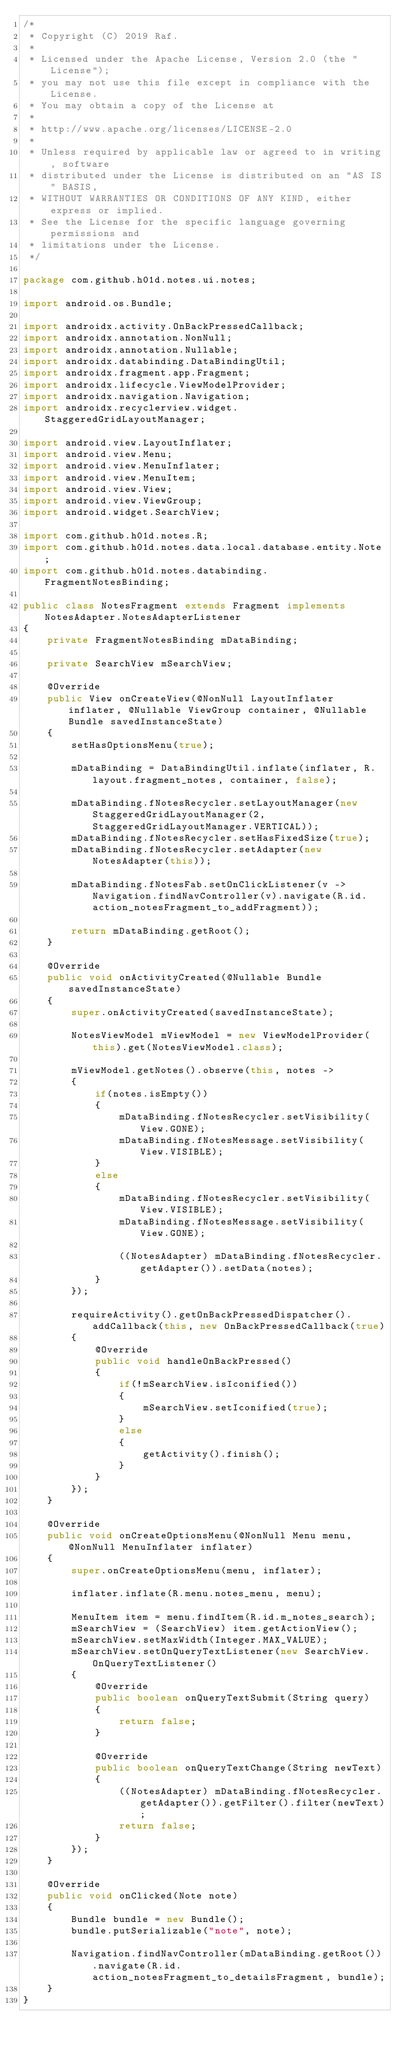Convert code to text. <code><loc_0><loc_0><loc_500><loc_500><_Java_>/*
 * Copyright (C) 2019 Raf.
 *
 * Licensed under the Apache License, Version 2.0 (the "License");
 * you may not use this file except in compliance with the License.
 * You may obtain a copy of the License at
 *
 * http://www.apache.org/licenses/LICENSE-2.0
 *
 * Unless required by applicable law or agreed to in writing, software
 * distributed under the License is distributed on an "AS IS" BASIS,
 * WITHOUT WARRANTIES OR CONDITIONS OF ANY KIND, either express or implied.
 * See the License for the specific language governing permissions and
 * limitations under the License.
 */

package com.github.h01d.notes.ui.notes;

import android.os.Bundle;

import androidx.activity.OnBackPressedCallback;
import androidx.annotation.NonNull;
import androidx.annotation.Nullable;
import androidx.databinding.DataBindingUtil;
import androidx.fragment.app.Fragment;
import androidx.lifecycle.ViewModelProvider;
import androidx.navigation.Navigation;
import androidx.recyclerview.widget.StaggeredGridLayoutManager;

import android.view.LayoutInflater;
import android.view.Menu;
import android.view.MenuInflater;
import android.view.MenuItem;
import android.view.View;
import android.view.ViewGroup;
import android.widget.SearchView;

import com.github.h01d.notes.R;
import com.github.h01d.notes.data.local.database.entity.Note;
import com.github.h01d.notes.databinding.FragmentNotesBinding;

public class NotesFragment extends Fragment implements NotesAdapter.NotesAdapterListener
{
    private FragmentNotesBinding mDataBinding;

    private SearchView mSearchView;

    @Override
    public View onCreateView(@NonNull LayoutInflater inflater, @Nullable ViewGroup container, @Nullable Bundle savedInstanceState)
    {
        setHasOptionsMenu(true);

        mDataBinding = DataBindingUtil.inflate(inflater, R.layout.fragment_notes, container, false);

        mDataBinding.fNotesRecycler.setLayoutManager(new StaggeredGridLayoutManager(2, StaggeredGridLayoutManager.VERTICAL));
        mDataBinding.fNotesRecycler.setHasFixedSize(true);
        mDataBinding.fNotesRecycler.setAdapter(new NotesAdapter(this));

        mDataBinding.fNotesFab.setOnClickListener(v -> Navigation.findNavController(v).navigate(R.id.action_notesFragment_to_addFragment));

        return mDataBinding.getRoot();
    }

    @Override
    public void onActivityCreated(@Nullable Bundle savedInstanceState)
    {
        super.onActivityCreated(savedInstanceState);

        NotesViewModel mViewModel = new ViewModelProvider(this).get(NotesViewModel.class);

        mViewModel.getNotes().observe(this, notes ->
        {
            if(notes.isEmpty())
            {
                mDataBinding.fNotesRecycler.setVisibility(View.GONE);
                mDataBinding.fNotesMessage.setVisibility(View.VISIBLE);
            }
            else
            {
                mDataBinding.fNotesRecycler.setVisibility(View.VISIBLE);
                mDataBinding.fNotesMessage.setVisibility(View.GONE);

                ((NotesAdapter) mDataBinding.fNotesRecycler.getAdapter()).setData(notes);
            }
        });

        requireActivity().getOnBackPressedDispatcher().addCallback(this, new OnBackPressedCallback(true)
        {
            @Override
            public void handleOnBackPressed()
            {
                if(!mSearchView.isIconified())
                {
                    mSearchView.setIconified(true);
                }
                else
                {
                    getActivity().finish();
                }
            }
        });
    }

    @Override
    public void onCreateOptionsMenu(@NonNull Menu menu, @NonNull MenuInflater inflater)
    {
        super.onCreateOptionsMenu(menu, inflater);

        inflater.inflate(R.menu.notes_menu, menu);

        MenuItem item = menu.findItem(R.id.m_notes_search);
        mSearchView = (SearchView) item.getActionView();
        mSearchView.setMaxWidth(Integer.MAX_VALUE);
        mSearchView.setOnQueryTextListener(new SearchView.OnQueryTextListener()
        {
            @Override
            public boolean onQueryTextSubmit(String query)
            {
                return false;
            }

            @Override
            public boolean onQueryTextChange(String newText)
            {
                ((NotesAdapter) mDataBinding.fNotesRecycler.getAdapter()).getFilter().filter(newText);
                return false;
            }
        });
    }

    @Override
    public void onClicked(Note note)
    {
        Bundle bundle = new Bundle();
        bundle.putSerializable("note", note);

        Navigation.findNavController(mDataBinding.getRoot()).navigate(R.id.action_notesFragment_to_detailsFragment, bundle);
    }
}
</code> 